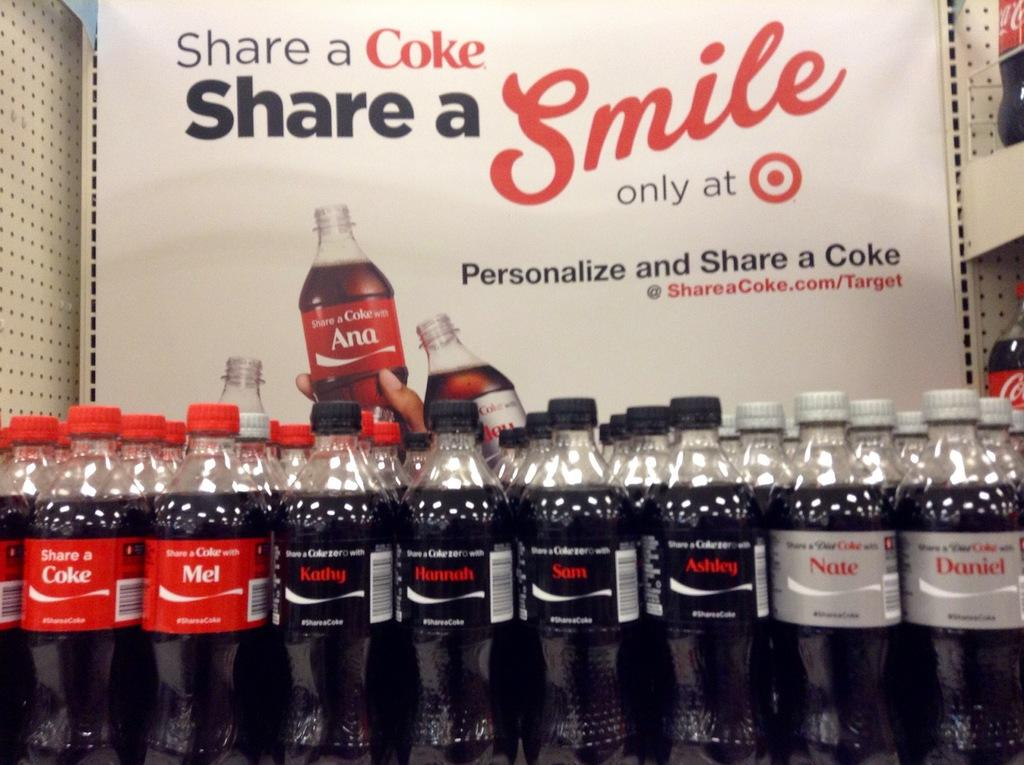Provide a one-sentence caption for the provided image. Sign that says share a coke share a smile only at target behind bottles of coke. 